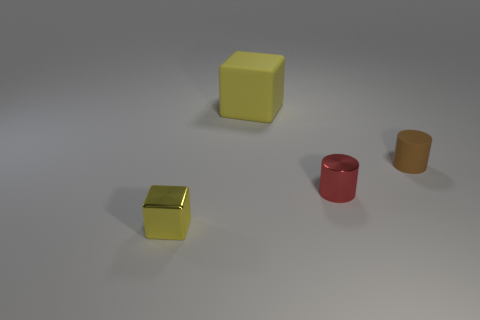Add 4 small yellow blocks. How many objects exist? 8 Subtract 0 gray spheres. How many objects are left? 4 Subtract all brown cylinders. Subtract all yellow blocks. How many objects are left? 1 Add 3 big yellow things. How many big yellow things are left? 4 Add 1 metal blocks. How many metal blocks exist? 2 